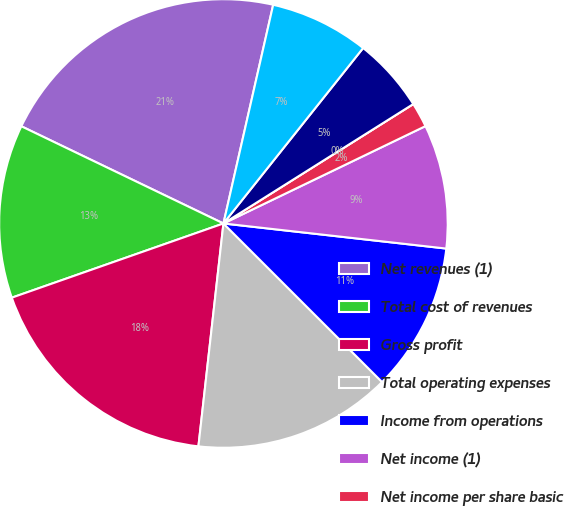<chart> <loc_0><loc_0><loc_500><loc_500><pie_chart><fcel>Net revenues (1)<fcel>Total cost of revenues<fcel>Gross profit<fcel>Total operating expenses<fcel>Income from operations<fcel>Net income (1)<fcel>Net income per share basic<fcel>Net income per share diluted<fcel>Shares used in basic<fcel>Shares used in diluted<nl><fcel>21.42%<fcel>12.5%<fcel>17.85%<fcel>14.28%<fcel>10.71%<fcel>8.93%<fcel>1.79%<fcel>0.0%<fcel>5.36%<fcel>7.14%<nl></chart> 